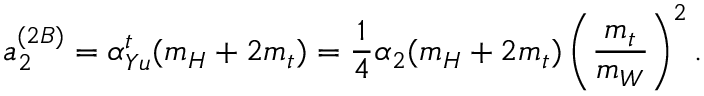Convert formula to latex. <formula><loc_0><loc_0><loc_500><loc_500>a _ { 2 } ^ { ( 2 B ) } = \alpha _ { Y u } ^ { t } ( m _ { H } + 2 m _ { t } ) = \frac { 1 } { 4 } \alpha _ { 2 } ( m _ { H } + 2 m _ { t } ) \left ( \frac { m _ { t } } { m _ { W } } \right ) ^ { 2 } .</formula> 